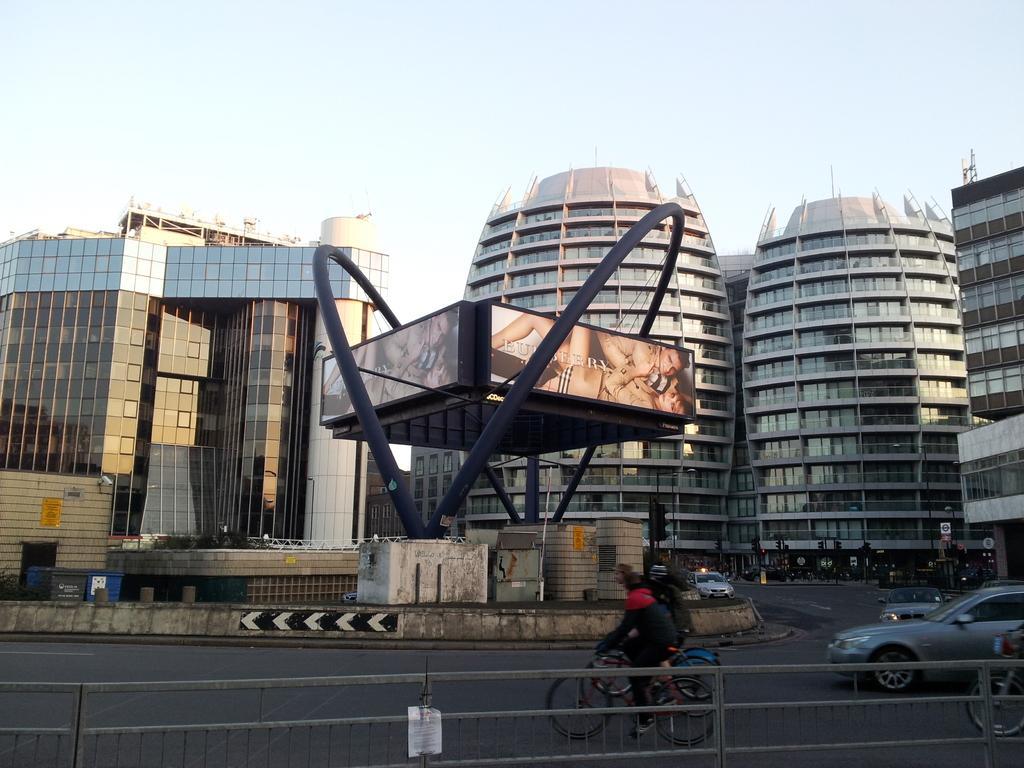Could you give a brief overview of what you see in this image? In this image I can see few vehicles on the road, in front the person is riding a big-cycle wearing black color dress. Background I can see few glass buildings and the sky is in white color. 